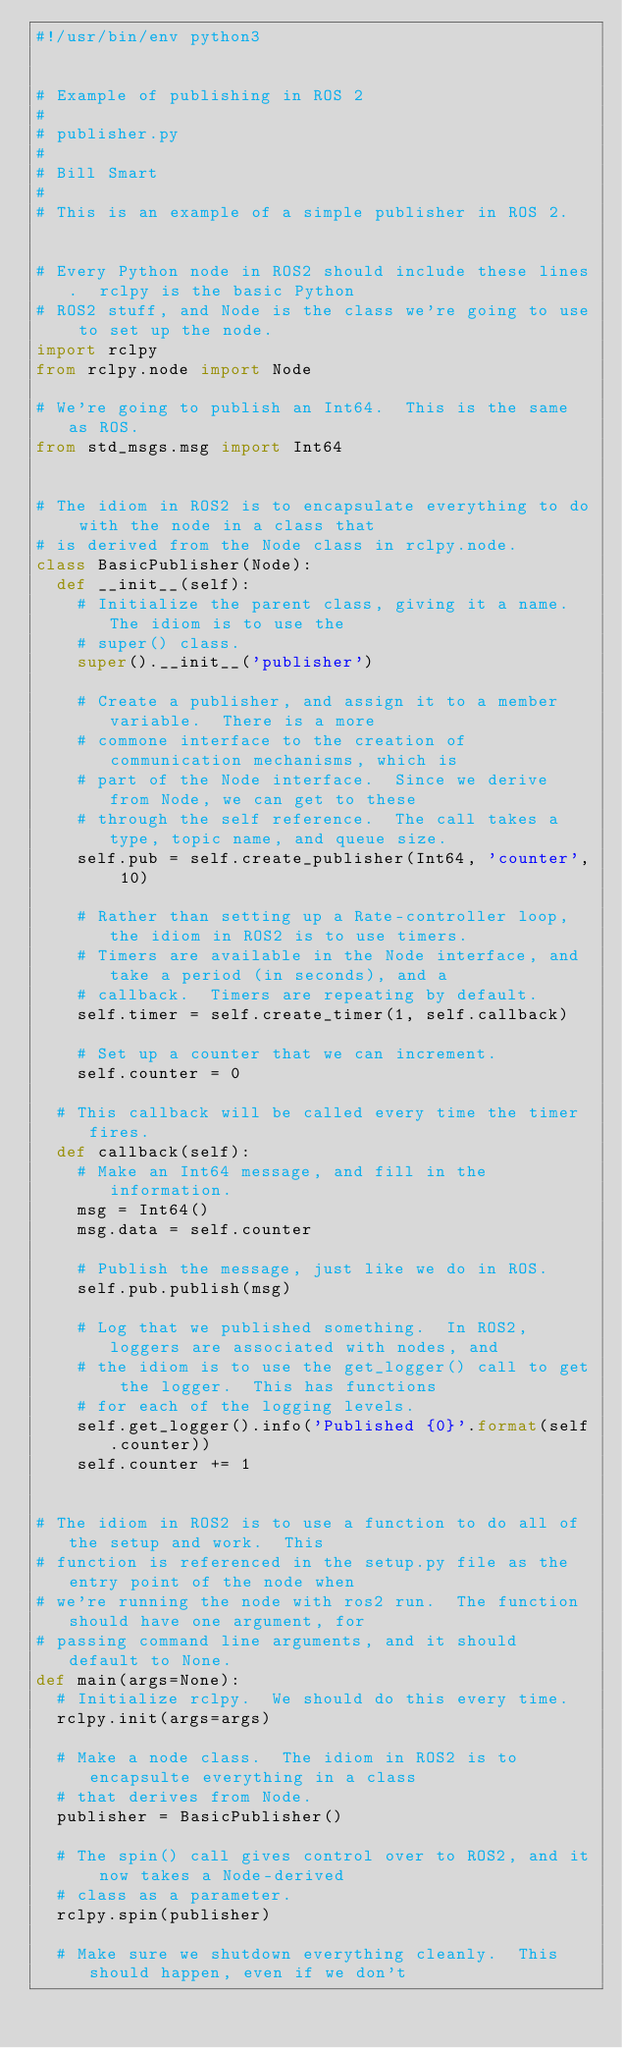<code> <loc_0><loc_0><loc_500><loc_500><_Python_>#!/usr/bin/env python3


# Example of publishing in ROS 2
#
# publisher.py
#
# Bill Smart
#
# This is an example of a simple publisher in ROS 2.


# Every Python node in ROS2 should include these lines.  rclpy is the basic Python
# ROS2 stuff, and Node is the class we're going to use to set up the node.
import rclpy
from rclpy.node import Node

# We're going to publish an Int64.  This is the same as ROS.
from std_msgs.msg import Int64


# The idiom in ROS2 is to encapsulate everything to do with the node in a class that
# is derived from the Node class in rclpy.node.
class BasicPublisher(Node):
	def __init__(self):
		# Initialize the parent class, giving it a name.  The idiom is to use the
		# super() class.
		super().__init__('publisher')

		# Create a publisher, and assign it to a member variable.  There is a more
		# commone interface to the creation of communication mechanisms, which is
		# part of the Node interface.  Since we derive from Node, we can get to these
		# through the self reference.  The call takes a type, topic name, and queue size.
		self.pub = self.create_publisher(Int64, 'counter', 10)

		# Rather than setting up a Rate-controller loop, the idiom in ROS2 is to use timers.
		# Timers are available in the Node interface, and take a period (in seconds), and a
		# callback.  Timers are repeating by default.
		self.timer = self.create_timer(1, self.callback)

		# Set up a counter that we can increment.
		self.counter = 0

	# This callback will be called every time the timer fires.
	def callback(self):
		# Make an Int64 message, and fill in the information.
		msg = Int64()
		msg.data = self.counter

		# Publish the message, just like we do in ROS.
		self.pub.publish(msg)

		# Log that we published something.  In ROS2, loggers are associated with nodes, and
		# the idiom is to use the get_logger() call to get the logger.  This has functions
		# for each of the logging levels.
		self.get_logger().info('Published {0}'.format(self.counter))
		self.counter += 1


# The idiom in ROS2 is to use a function to do all of the setup and work.  This
# function is referenced in the setup.py file as the entry point of the node when
# we're running the node with ros2 run.  The function should have one argument, for
# passing command line arguments, and it should default to None.
def main(args=None):
	# Initialize rclpy.  We should do this every time.
	rclpy.init(args=args)

	# Make a node class.  The idiom in ROS2 is to encapsulte everything in a class
	# that derives from Node.
	publisher = BasicPublisher()

	# The spin() call gives control over to ROS2, and it now takes a Node-derived
	# class as a parameter.
	rclpy.spin(publisher)

	# Make sure we shutdown everything cleanly.  This should happen, even if we don't</code> 